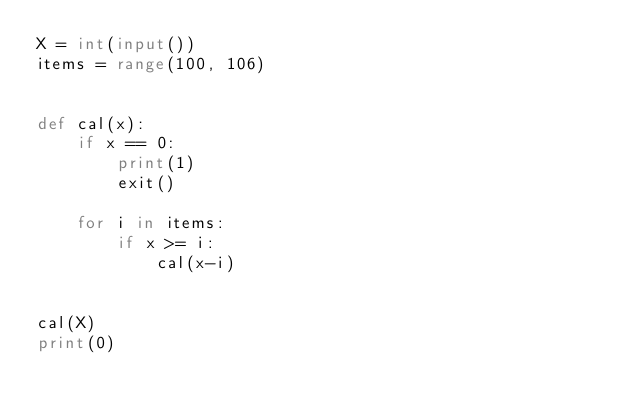<code> <loc_0><loc_0><loc_500><loc_500><_Python_>X = int(input())
items = range(100, 106)


def cal(x):
    if x == 0:
        print(1)
        exit()

    for i in items:
        if x >= i:
            cal(x-i)


cal(X)
print(0)
</code> 